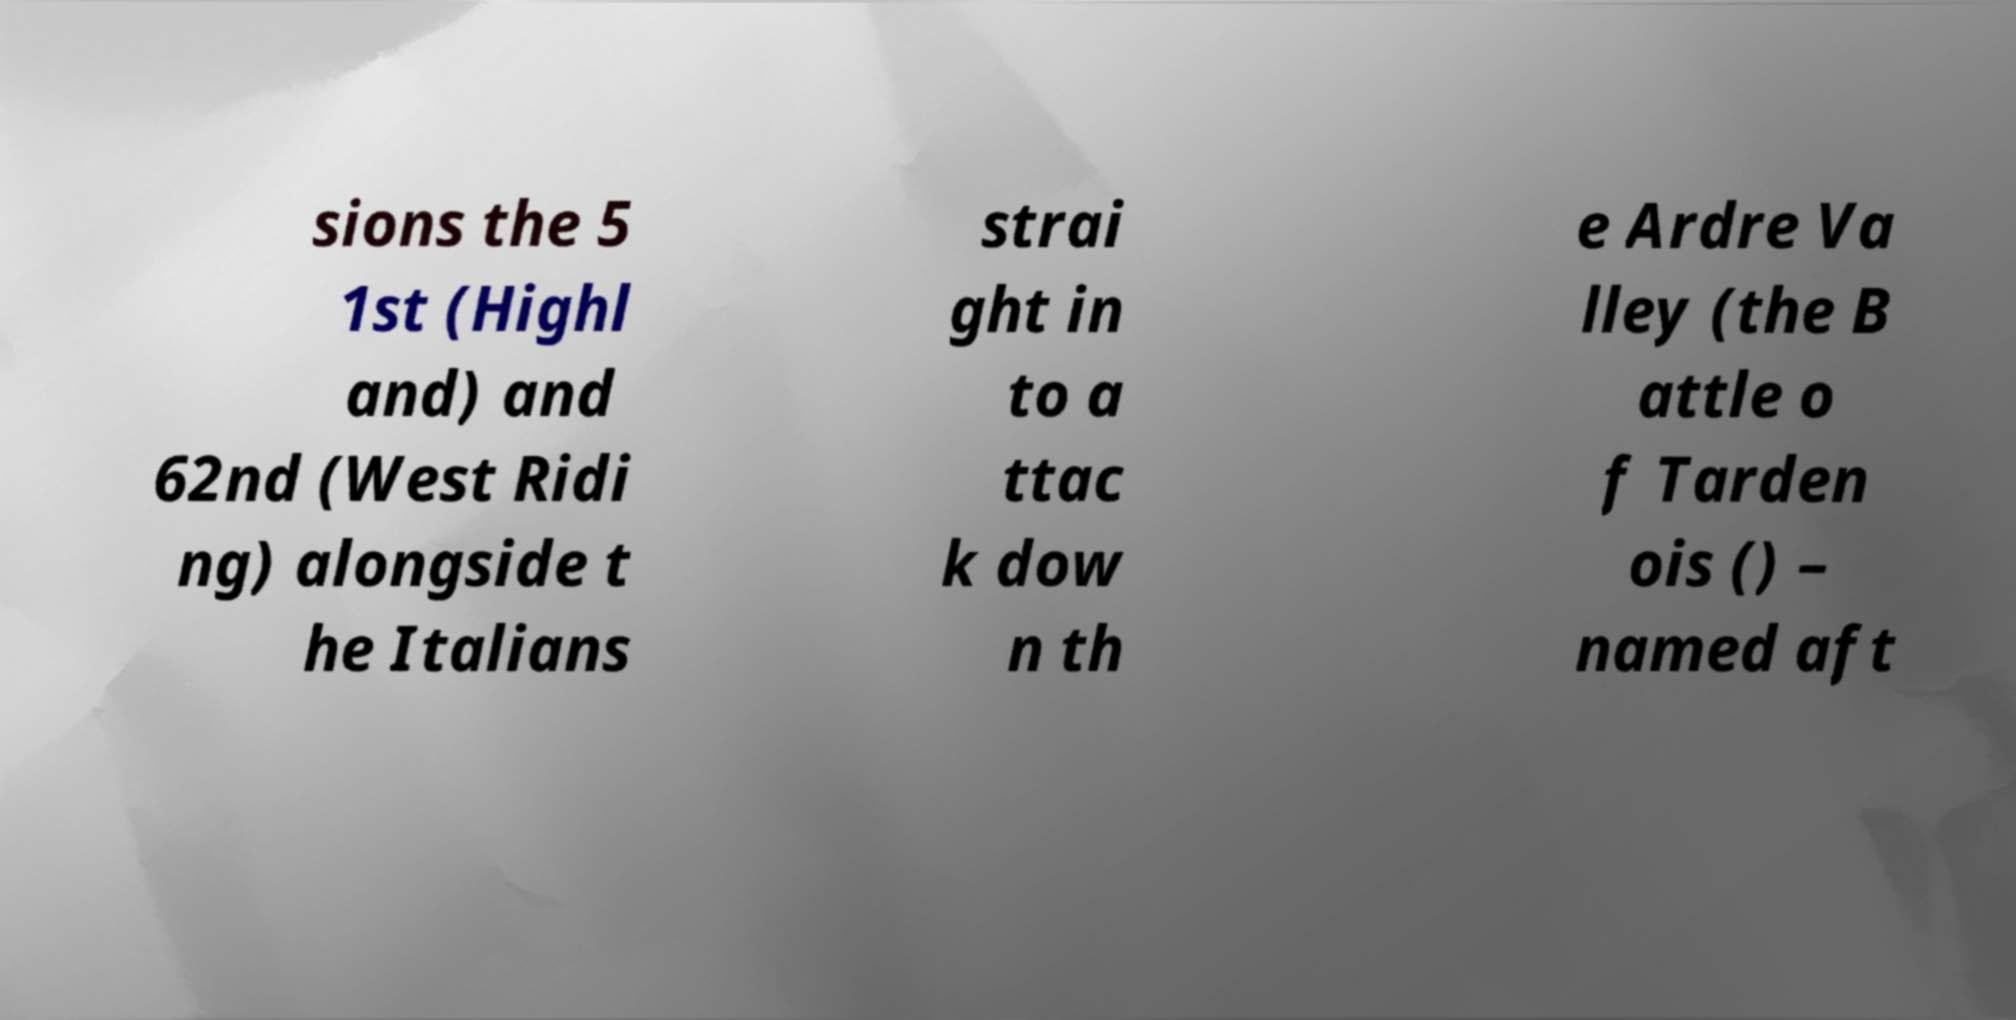There's text embedded in this image that I need extracted. Can you transcribe it verbatim? sions the 5 1st (Highl and) and 62nd (West Ridi ng) alongside t he Italians strai ght in to a ttac k dow n th e Ardre Va lley (the B attle o f Tarden ois () – named aft 